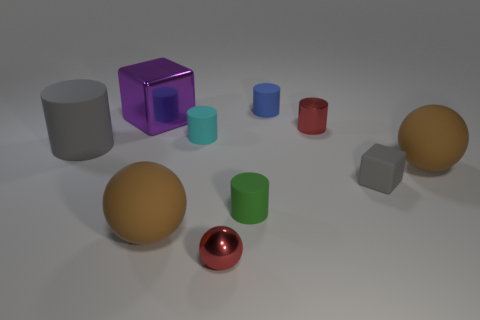Subtract all tiny cylinders. How many cylinders are left? 1 Subtract all red spheres. How many spheres are left? 2 Subtract all spheres. How many objects are left? 7 Subtract 1 cubes. How many cubes are left? 1 Subtract all brown cubes. Subtract all purple cylinders. How many cubes are left? 2 Subtract all green cylinders. How many blue cubes are left? 0 Subtract all brown rubber spheres. Subtract all brown objects. How many objects are left? 6 Add 1 brown balls. How many brown balls are left? 3 Add 6 tiny yellow metallic cylinders. How many tiny yellow metallic cylinders exist? 6 Subtract 0 purple spheres. How many objects are left? 10 